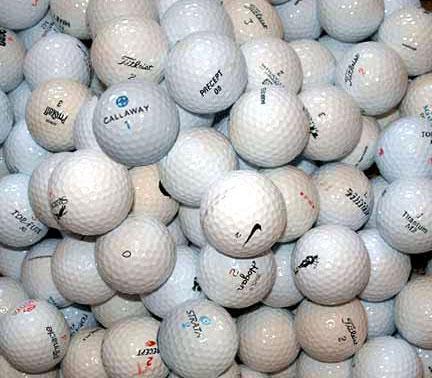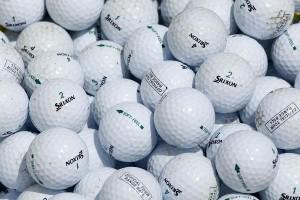The first image is the image on the left, the second image is the image on the right. Examine the images to the left and right. Is the description "Some of the balls have an orange print" accurate? Answer yes or no. No. The first image is the image on the left, the second image is the image on the right. Analyze the images presented: Is the assertion "The balls in the image on the left are not in shadow" valid? Answer yes or no. Yes. 